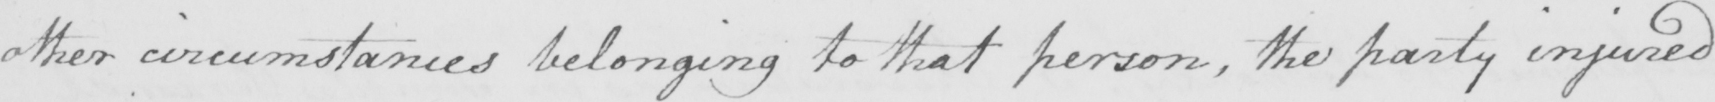What text is written in this handwritten line? other circumstances belonging to that person , the party injured 